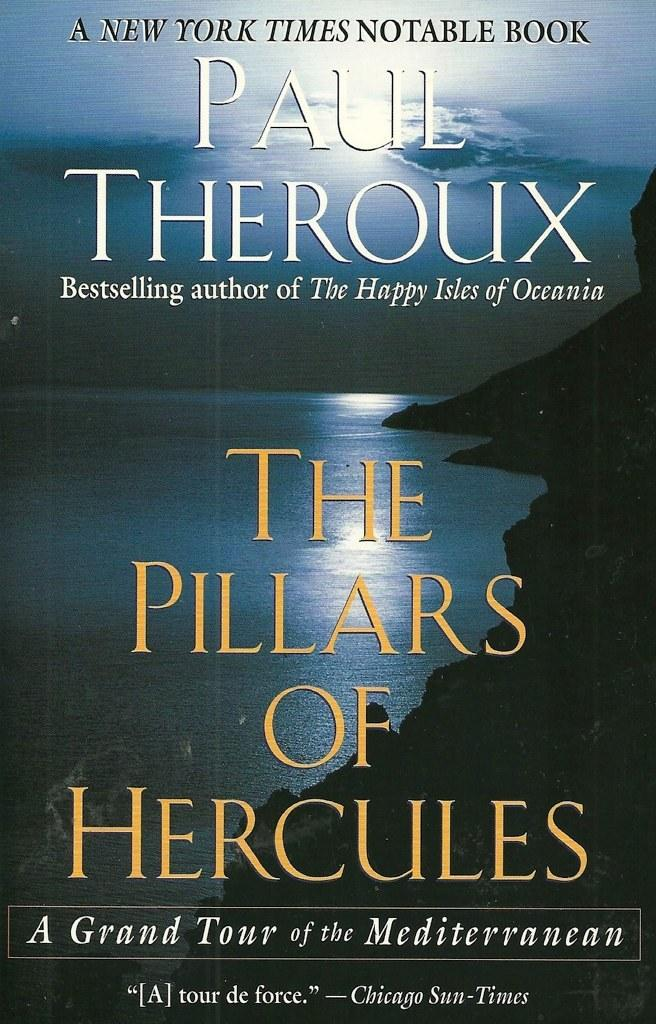<image>
Share a concise interpretation of the image provided. The book The Pillars of Hercules was written by Paul Theroux. 